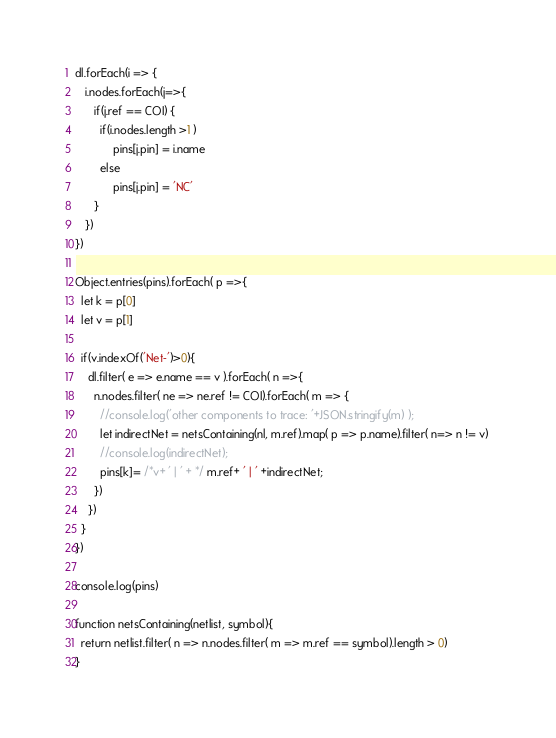<code> <loc_0><loc_0><loc_500><loc_500><_JavaScript_>dl.forEach(i => {
   i.nodes.forEach(j=>{
      if(j.ref == COI) {
        if(i.nodes.length >1 )
            pins[j.pin] = i.name
        else
            pins[j.pin] = 'NC'
      }
   }) 
})

Object.entries(pins).forEach( p =>{
  let k = p[0]
  let v = p[1]

  if(v.indexOf('Net-')>0){
    dl.filter( e => e.name == v ).forEach( n =>{
      n.nodes.filter( ne => ne.ref != COI).forEach( m => {
        //console.log('other components to trace: '+JSON.stringify(m) );
        let indirectNet = netsContaining(nl, m.ref).map( p => p.name).filter( n=> n != v) 
        //console.log(indirectNet); 
        pins[k]= /*v+ ' | ' + */ m.ref+ ' | ' +indirectNet;
      })
    })
  }
})

console.log(pins)

function netsContaining(netlist, symbol){
  return netlist.filter( n => n.nodes.filter( m => m.ref == symbol).length > 0)
}
</code> 